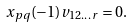Convert formula to latex. <formula><loc_0><loc_0><loc_500><loc_500>x _ { p q } ( - 1 ) v _ { 1 2 \dots r } = 0 .</formula> 